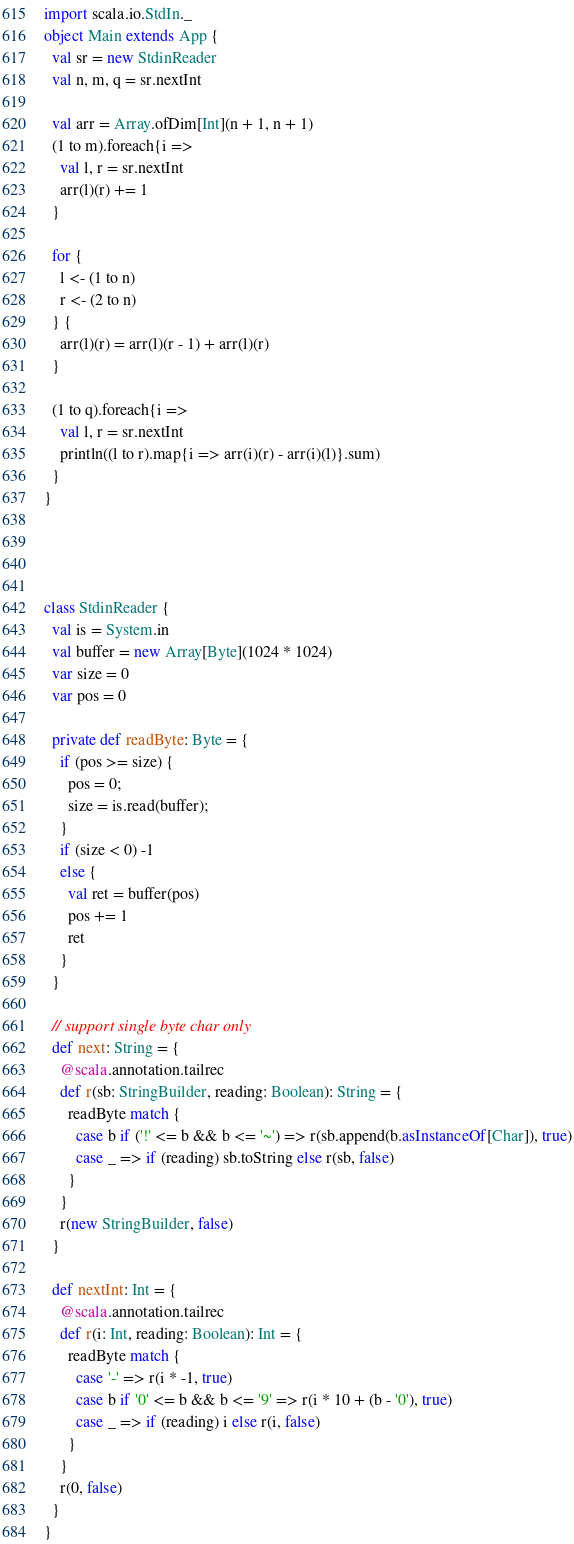Convert code to text. <code><loc_0><loc_0><loc_500><loc_500><_Scala_>import scala.io.StdIn._
object Main extends App {
  val sr = new StdinReader
  val n, m, q = sr.nextInt

  val arr = Array.ofDim[Int](n + 1, n + 1)
  (1 to m).foreach{i =>
    val l, r = sr.nextInt
    arr(l)(r) += 1
  }

  for {
    l <- (1 to n)
    r <- (2 to n)
  } {
    arr(l)(r) = arr(l)(r - 1) + arr(l)(r)
  }

  (1 to q).foreach{i =>
    val l, r = sr.nextInt
    println((l to r).map{i => arr(i)(r) - arr(i)(l)}.sum)
  }
}




class StdinReader {
  val is = System.in
  val buffer = new Array[Byte](1024 * 1024)
  var size = 0
  var pos = 0

  private def readByte: Byte = {
    if (pos >= size) {
      pos = 0;
      size = is.read(buffer);
    }
    if (size < 0) -1
    else {
      val ret = buffer(pos)
      pos += 1
      ret
    }
  }

  // support single byte char only
  def next: String = {
    @scala.annotation.tailrec
    def r(sb: StringBuilder, reading: Boolean): String = {
      readByte match {
        case b if ('!' <= b && b <= '~') => r(sb.append(b.asInstanceOf[Char]), true)
        case _ => if (reading) sb.toString else r(sb, false)
      }
    }
    r(new StringBuilder, false)
  }

  def nextInt: Int = {
    @scala.annotation.tailrec
    def r(i: Int, reading: Boolean): Int = {
      readByte match {
        case '-' => r(i * -1, true)
        case b if '0' <= b && b <= '9' => r(i * 10 + (b - '0'), true)
        case _ => if (reading) i else r(i, false)
      }
    }
    r(0, false)
  }
}</code> 